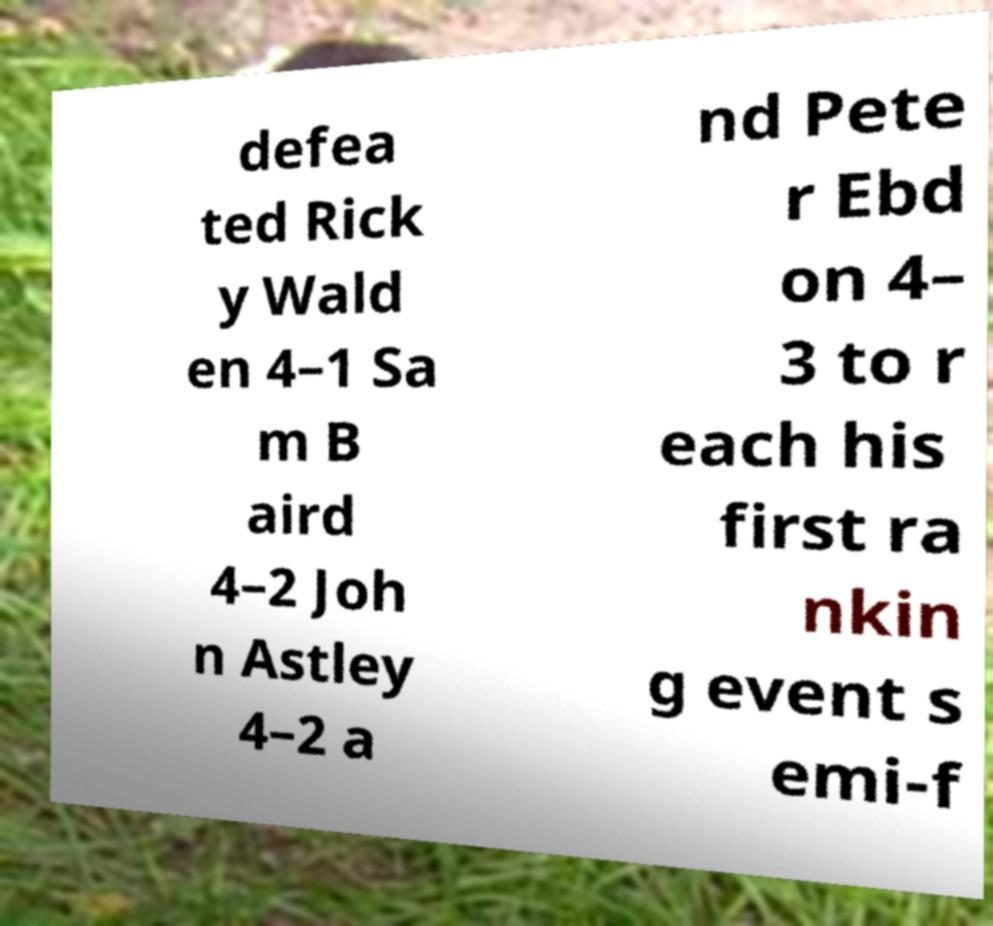Can you read and provide the text displayed in the image?This photo seems to have some interesting text. Can you extract and type it out for me? defea ted Rick y Wald en 4–1 Sa m B aird 4–2 Joh n Astley 4–2 a nd Pete r Ebd on 4– 3 to r each his first ra nkin g event s emi-f 